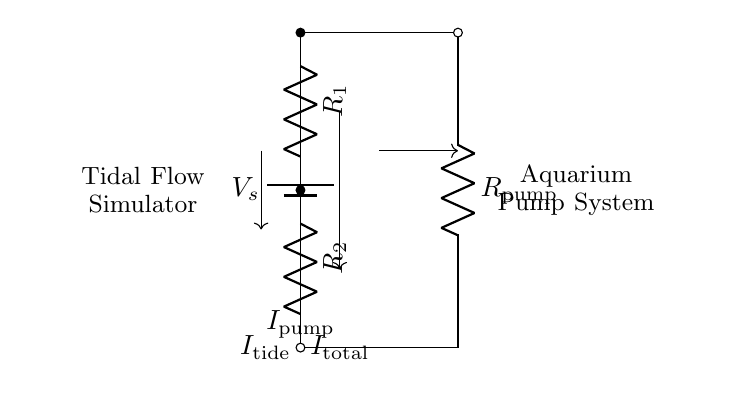What is the total current in the circuit? The total current is indicated as I total, which is the sum of the currents flowing through the circuit. In the current divider configuration, the total current splits between R1 and R2.
Answer: I total What components are used in this circuit? The circuit consists of a voltage source, two resistors (R1 and R2), and a pump (R pump). These key components define the circuit's functionality.
Answer: Voltage source, R1, R2, R pump What type of circuit is this? This is a current divider circuit. A current divider splits the input current into multiple branches.
Answer: Current divider What is the purpose of R pump? R pump represents the aquarium pump's resistance, which allows for the simulation of tidal flows by controlling how much current passes through it.
Answer: To simulate tidal flows How many branches does this circuit have? The circuit has three branches: one for the tidal flow simulator, one for resistor R1, and one for resistor R2.
Answer: Three What happens to the current if R1 is decreased? If R1 is decreased, the total current will still be I total, but more current will flow through R1 due to the reduced resistance, altering the distribution of current in the circuit.
Answer: More current through R1 